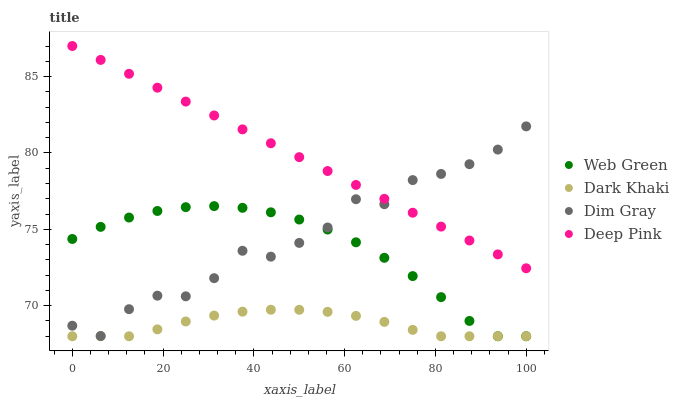Does Dark Khaki have the minimum area under the curve?
Answer yes or no. Yes. Does Deep Pink have the maximum area under the curve?
Answer yes or no. Yes. Does Dim Gray have the minimum area under the curve?
Answer yes or no. No. Does Dim Gray have the maximum area under the curve?
Answer yes or no. No. Is Deep Pink the smoothest?
Answer yes or no. Yes. Is Dim Gray the roughest?
Answer yes or no. Yes. Is Web Green the smoothest?
Answer yes or no. No. Is Web Green the roughest?
Answer yes or no. No. Does Dark Khaki have the lowest value?
Answer yes or no. Yes. Does Dim Gray have the lowest value?
Answer yes or no. No. Does Deep Pink have the highest value?
Answer yes or no. Yes. Does Dim Gray have the highest value?
Answer yes or no. No. Is Web Green less than Deep Pink?
Answer yes or no. Yes. Is Dim Gray greater than Dark Khaki?
Answer yes or no. Yes. Does Deep Pink intersect Dim Gray?
Answer yes or no. Yes. Is Deep Pink less than Dim Gray?
Answer yes or no. No. Is Deep Pink greater than Dim Gray?
Answer yes or no. No. Does Web Green intersect Deep Pink?
Answer yes or no. No. 